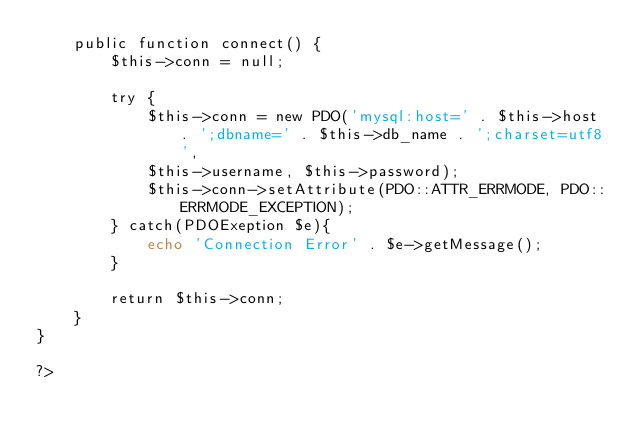<code> <loc_0><loc_0><loc_500><loc_500><_PHP_>    public function connect() {
        $this->conn = null;

        try {
            $this->conn = new PDO('mysql:host=' . $this->host . ';dbname=' . $this->db_name . ';charset=utf8',
            $this->username, $this->password);
            $this->conn->setAttribute(PDO::ATTR_ERRMODE, PDO::ERRMODE_EXCEPTION);
        } catch(PDOExeption $e){
            echo 'Connection Error' . $e->getMessage();
        }

        return $this->conn;
    }
}

?></code> 